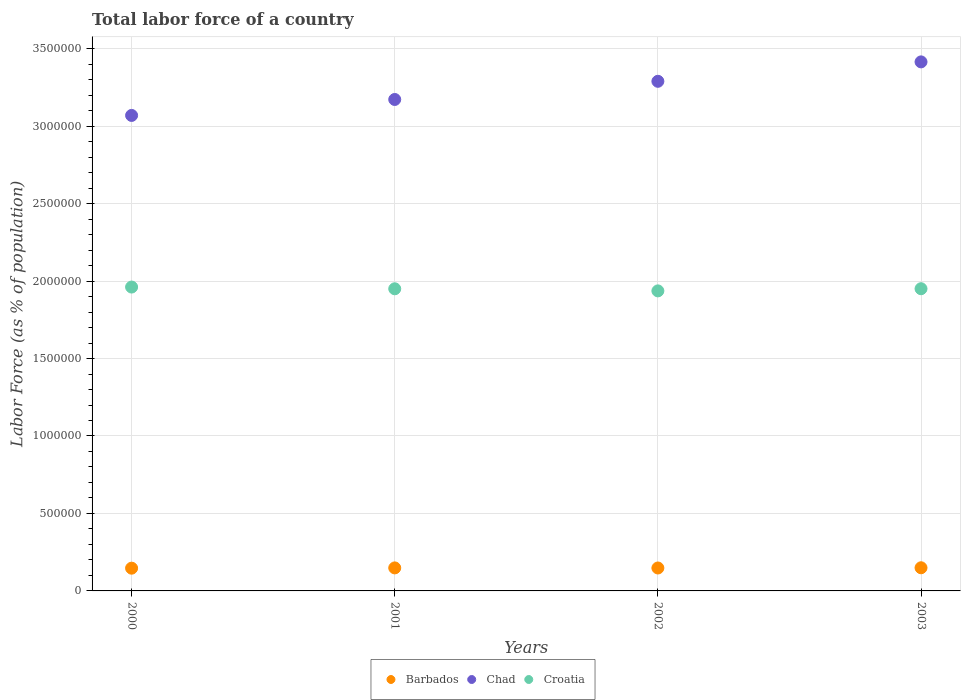Is the number of dotlines equal to the number of legend labels?
Give a very brief answer. Yes. What is the percentage of labor force in Barbados in 2002?
Your answer should be very brief. 1.48e+05. Across all years, what is the maximum percentage of labor force in Chad?
Your response must be concise. 3.41e+06. Across all years, what is the minimum percentage of labor force in Barbados?
Ensure brevity in your answer.  1.47e+05. In which year was the percentage of labor force in Croatia minimum?
Ensure brevity in your answer.  2002. What is the total percentage of labor force in Barbados in the graph?
Give a very brief answer. 5.93e+05. What is the difference between the percentage of labor force in Chad in 2000 and that in 2003?
Your answer should be compact. -3.46e+05. What is the difference between the percentage of labor force in Croatia in 2003 and the percentage of labor force in Barbados in 2000?
Make the answer very short. 1.80e+06. What is the average percentage of labor force in Chad per year?
Your response must be concise. 3.24e+06. In the year 2003, what is the difference between the percentage of labor force in Barbados and percentage of labor force in Croatia?
Your answer should be compact. -1.80e+06. In how many years, is the percentage of labor force in Chad greater than 1500000 %?
Keep it short and to the point. 4. What is the ratio of the percentage of labor force in Croatia in 2000 to that in 2002?
Keep it short and to the point. 1.01. Is the percentage of labor force in Croatia in 2001 less than that in 2002?
Ensure brevity in your answer.  No. Is the difference between the percentage of labor force in Barbados in 2002 and 2003 greater than the difference between the percentage of labor force in Croatia in 2002 and 2003?
Give a very brief answer. Yes. What is the difference between the highest and the second highest percentage of labor force in Barbados?
Offer a very short reply. 893. What is the difference between the highest and the lowest percentage of labor force in Barbados?
Your answer should be very brief. 2651. Is it the case that in every year, the sum of the percentage of labor force in Chad and percentage of labor force in Croatia  is greater than the percentage of labor force in Barbados?
Give a very brief answer. Yes. Does the percentage of labor force in Chad monotonically increase over the years?
Provide a succinct answer. Yes. Is the percentage of labor force in Barbados strictly greater than the percentage of labor force in Croatia over the years?
Ensure brevity in your answer.  No. How many dotlines are there?
Your response must be concise. 3. How many years are there in the graph?
Your response must be concise. 4. What is the difference between two consecutive major ticks on the Y-axis?
Make the answer very short. 5.00e+05. Are the values on the major ticks of Y-axis written in scientific E-notation?
Provide a succinct answer. No. Does the graph contain any zero values?
Your answer should be very brief. No. Does the graph contain grids?
Keep it short and to the point. Yes. Where does the legend appear in the graph?
Give a very brief answer. Bottom center. What is the title of the graph?
Your answer should be compact. Total labor force of a country. Does "Portugal" appear as one of the legend labels in the graph?
Offer a terse response. No. What is the label or title of the Y-axis?
Offer a very short reply. Labor Force (as % of population). What is the Labor Force (as % of population) in Barbados in 2000?
Your response must be concise. 1.47e+05. What is the Labor Force (as % of population) of Chad in 2000?
Give a very brief answer. 3.07e+06. What is the Labor Force (as % of population) of Croatia in 2000?
Your answer should be very brief. 1.96e+06. What is the Labor Force (as % of population) of Barbados in 2001?
Ensure brevity in your answer.  1.49e+05. What is the Labor Force (as % of population) of Chad in 2001?
Offer a terse response. 3.17e+06. What is the Labor Force (as % of population) of Croatia in 2001?
Your response must be concise. 1.95e+06. What is the Labor Force (as % of population) of Barbados in 2002?
Your response must be concise. 1.48e+05. What is the Labor Force (as % of population) of Chad in 2002?
Provide a succinct answer. 3.29e+06. What is the Labor Force (as % of population) in Croatia in 2002?
Your response must be concise. 1.94e+06. What is the Labor Force (as % of population) in Barbados in 2003?
Your answer should be compact. 1.49e+05. What is the Labor Force (as % of population) of Chad in 2003?
Offer a terse response. 3.41e+06. What is the Labor Force (as % of population) of Croatia in 2003?
Provide a succinct answer. 1.95e+06. Across all years, what is the maximum Labor Force (as % of population) in Barbados?
Give a very brief answer. 1.49e+05. Across all years, what is the maximum Labor Force (as % of population) in Chad?
Provide a short and direct response. 3.41e+06. Across all years, what is the maximum Labor Force (as % of population) of Croatia?
Keep it short and to the point. 1.96e+06. Across all years, what is the minimum Labor Force (as % of population) of Barbados?
Give a very brief answer. 1.47e+05. Across all years, what is the minimum Labor Force (as % of population) of Chad?
Keep it short and to the point. 3.07e+06. Across all years, what is the minimum Labor Force (as % of population) of Croatia?
Keep it short and to the point. 1.94e+06. What is the total Labor Force (as % of population) in Barbados in the graph?
Give a very brief answer. 5.93e+05. What is the total Labor Force (as % of population) of Chad in the graph?
Provide a succinct answer. 1.29e+07. What is the total Labor Force (as % of population) in Croatia in the graph?
Provide a short and direct response. 7.80e+06. What is the difference between the Labor Force (as % of population) of Barbados in 2000 and that in 2001?
Keep it short and to the point. -1758. What is the difference between the Labor Force (as % of population) of Chad in 2000 and that in 2001?
Ensure brevity in your answer.  -1.03e+05. What is the difference between the Labor Force (as % of population) in Croatia in 2000 and that in 2001?
Give a very brief answer. 1.12e+04. What is the difference between the Labor Force (as % of population) of Barbados in 2000 and that in 2002?
Your answer should be very brief. -1194. What is the difference between the Labor Force (as % of population) of Chad in 2000 and that in 2002?
Keep it short and to the point. -2.20e+05. What is the difference between the Labor Force (as % of population) of Croatia in 2000 and that in 2002?
Make the answer very short. 2.47e+04. What is the difference between the Labor Force (as % of population) of Barbados in 2000 and that in 2003?
Provide a short and direct response. -2651. What is the difference between the Labor Force (as % of population) of Chad in 2000 and that in 2003?
Your answer should be compact. -3.46e+05. What is the difference between the Labor Force (as % of population) in Croatia in 2000 and that in 2003?
Offer a very short reply. 1.08e+04. What is the difference between the Labor Force (as % of population) of Barbados in 2001 and that in 2002?
Offer a terse response. 564. What is the difference between the Labor Force (as % of population) of Chad in 2001 and that in 2002?
Keep it short and to the point. -1.17e+05. What is the difference between the Labor Force (as % of population) in Croatia in 2001 and that in 2002?
Offer a very short reply. 1.36e+04. What is the difference between the Labor Force (as % of population) in Barbados in 2001 and that in 2003?
Make the answer very short. -893. What is the difference between the Labor Force (as % of population) of Chad in 2001 and that in 2003?
Your answer should be very brief. -2.43e+05. What is the difference between the Labor Force (as % of population) in Croatia in 2001 and that in 2003?
Provide a succinct answer. -416. What is the difference between the Labor Force (as % of population) of Barbados in 2002 and that in 2003?
Your answer should be very brief. -1457. What is the difference between the Labor Force (as % of population) in Chad in 2002 and that in 2003?
Provide a succinct answer. -1.25e+05. What is the difference between the Labor Force (as % of population) in Croatia in 2002 and that in 2003?
Give a very brief answer. -1.40e+04. What is the difference between the Labor Force (as % of population) of Barbados in 2000 and the Labor Force (as % of population) of Chad in 2001?
Give a very brief answer. -3.03e+06. What is the difference between the Labor Force (as % of population) of Barbados in 2000 and the Labor Force (as % of population) of Croatia in 2001?
Provide a succinct answer. -1.80e+06. What is the difference between the Labor Force (as % of population) of Chad in 2000 and the Labor Force (as % of population) of Croatia in 2001?
Your answer should be very brief. 1.12e+06. What is the difference between the Labor Force (as % of population) in Barbados in 2000 and the Labor Force (as % of population) in Chad in 2002?
Make the answer very short. -3.14e+06. What is the difference between the Labor Force (as % of population) in Barbados in 2000 and the Labor Force (as % of population) in Croatia in 2002?
Provide a succinct answer. -1.79e+06. What is the difference between the Labor Force (as % of population) in Chad in 2000 and the Labor Force (as % of population) in Croatia in 2002?
Give a very brief answer. 1.13e+06. What is the difference between the Labor Force (as % of population) of Barbados in 2000 and the Labor Force (as % of population) of Chad in 2003?
Make the answer very short. -3.27e+06. What is the difference between the Labor Force (as % of population) of Barbados in 2000 and the Labor Force (as % of population) of Croatia in 2003?
Your answer should be compact. -1.80e+06. What is the difference between the Labor Force (as % of population) in Chad in 2000 and the Labor Force (as % of population) in Croatia in 2003?
Offer a very short reply. 1.12e+06. What is the difference between the Labor Force (as % of population) of Barbados in 2001 and the Labor Force (as % of population) of Chad in 2002?
Keep it short and to the point. -3.14e+06. What is the difference between the Labor Force (as % of population) of Barbados in 2001 and the Labor Force (as % of population) of Croatia in 2002?
Ensure brevity in your answer.  -1.79e+06. What is the difference between the Labor Force (as % of population) in Chad in 2001 and the Labor Force (as % of population) in Croatia in 2002?
Provide a succinct answer. 1.24e+06. What is the difference between the Labor Force (as % of population) in Barbados in 2001 and the Labor Force (as % of population) in Chad in 2003?
Keep it short and to the point. -3.27e+06. What is the difference between the Labor Force (as % of population) in Barbados in 2001 and the Labor Force (as % of population) in Croatia in 2003?
Provide a short and direct response. -1.80e+06. What is the difference between the Labor Force (as % of population) of Chad in 2001 and the Labor Force (as % of population) of Croatia in 2003?
Your answer should be compact. 1.22e+06. What is the difference between the Labor Force (as % of population) in Barbados in 2002 and the Labor Force (as % of population) in Chad in 2003?
Provide a short and direct response. -3.27e+06. What is the difference between the Labor Force (as % of population) in Barbados in 2002 and the Labor Force (as % of population) in Croatia in 2003?
Ensure brevity in your answer.  -1.80e+06. What is the difference between the Labor Force (as % of population) in Chad in 2002 and the Labor Force (as % of population) in Croatia in 2003?
Offer a terse response. 1.34e+06. What is the average Labor Force (as % of population) in Barbados per year?
Keep it short and to the point. 1.48e+05. What is the average Labor Force (as % of population) in Chad per year?
Your response must be concise. 3.24e+06. What is the average Labor Force (as % of population) in Croatia per year?
Offer a very short reply. 1.95e+06. In the year 2000, what is the difference between the Labor Force (as % of population) in Barbados and Labor Force (as % of population) in Chad?
Provide a succinct answer. -2.92e+06. In the year 2000, what is the difference between the Labor Force (as % of population) in Barbados and Labor Force (as % of population) in Croatia?
Keep it short and to the point. -1.81e+06. In the year 2000, what is the difference between the Labor Force (as % of population) in Chad and Labor Force (as % of population) in Croatia?
Give a very brief answer. 1.11e+06. In the year 2001, what is the difference between the Labor Force (as % of population) in Barbados and Labor Force (as % of population) in Chad?
Keep it short and to the point. -3.02e+06. In the year 2001, what is the difference between the Labor Force (as % of population) in Barbados and Labor Force (as % of population) in Croatia?
Ensure brevity in your answer.  -1.80e+06. In the year 2001, what is the difference between the Labor Force (as % of population) of Chad and Labor Force (as % of population) of Croatia?
Keep it short and to the point. 1.22e+06. In the year 2002, what is the difference between the Labor Force (as % of population) of Barbados and Labor Force (as % of population) of Chad?
Offer a terse response. -3.14e+06. In the year 2002, what is the difference between the Labor Force (as % of population) in Barbados and Labor Force (as % of population) in Croatia?
Your answer should be compact. -1.79e+06. In the year 2002, what is the difference between the Labor Force (as % of population) of Chad and Labor Force (as % of population) of Croatia?
Offer a terse response. 1.35e+06. In the year 2003, what is the difference between the Labor Force (as % of population) of Barbados and Labor Force (as % of population) of Chad?
Your answer should be compact. -3.27e+06. In the year 2003, what is the difference between the Labor Force (as % of population) of Barbados and Labor Force (as % of population) of Croatia?
Your answer should be very brief. -1.80e+06. In the year 2003, what is the difference between the Labor Force (as % of population) of Chad and Labor Force (as % of population) of Croatia?
Provide a short and direct response. 1.46e+06. What is the ratio of the Labor Force (as % of population) in Barbados in 2000 to that in 2001?
Your response must be concise. 0.99. What is the ratio of the Labor Force (as % of population) in Chad in 2000 to that in 2001?
Ensure brevity in your answer.  0.97. What is the ratio of the Labor Force (as % of population) in Croatia in 2000 to that in 2001?
Your answer should be very brief. 1.01. What is the ratio of the Labor Force (as % of population) of Barbados in 2000 to that in 2002?
Your answer should be compact. 0.99. What is the ratio of the Labor Force (as % of population) of Chad in 2000 to that in 2002?
Your answer should be compact. 0.93. What is the ratio of the Labor Force (as % of population) in Croatia in 2000 to that in 2002?
Provide a short and direct response. 1.01. What is the ratio of the Labor Force (as % of population) of Barbados in 2000 to that in 2003?
Ensure brevity in your answer.  0.98. What is the ratio of the Labor Force (as % of population) in Chad in 2000 to that in 2003?
Provide a succinct answer. 0.9. What is the ratio of the Labor Force (as % of population) in Croatia in 2000 to that in 2003?
Your answer should be compact. 1.01. What is the ratio of the Labor Force (as % of population) in Barbados in 2001 to that in 2003?
Ensure brevity in your answer.  0.99. What is the ratio of the Labor Force (as % of population) in Chad in 2001 to that in 2003?
Offer a very short reply. 0.93. What is the ratio of the Labor Force (as % of population) in Barbados in 2002 to that in 2003?
Your answer should be compact. 0.99. What is the ratio of the Labor Force (as % of population) in Chad in 2002 to that in 2003?
Your answer should be very brief. 0.96. What is the difference between the highest and the second highest Labor Force (as % of population) in Barbados?
Offer a very short reply. 893. What is the difference between the highest and the second highest Labor Force (as % of population) in Chad?
Give a very brief answer. 1.25e+05. What is the difference between the highest and the second highest Labor Force (as % of population) in Croatia?
Your response must be concise. 1.08e+04. What is the difference between the highest and the lowest Labor Force (as % of population) in Barbados?
Keep it short and to the point. 2651. What is the difference between the highest and the lowest Labor Force (as % of population) of Chad?
Offer a very short reply. 3.46e+05. What is the difference between the highest and the lowest Labor Force (as % of population) in Croatia?
Offer a terse response. 2.47e+04. 